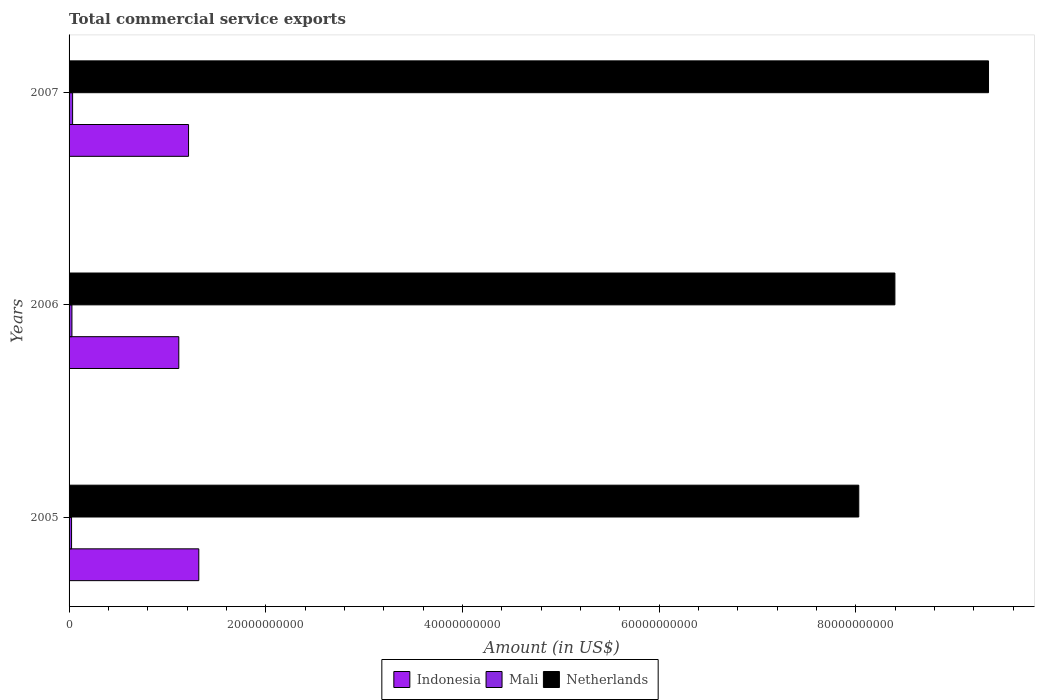How many different coloured bars are there?
Offer a very short reply. 3. How many groups of bars are there?
Offer a very short reply. 3. How many bars are there on the 2nd tick from the top?
Give a very brief answer. 3. What is the label of the 2nd group of bars from the top?
Keep it short and to the point. 2006. What is the total commercial service exports in Mali in 2005?
Offer a terse response. 2.54e+08. Across all years, what is the maximum total commercial service exports in Indonesia?
Your response must be concise. 1.32e+1. Across all years, what is the minimum total commercial service exports in Netherlands?
Offer a very short reply. 8.03e+1. What is the total total commercial service exports in Netherlands in the graph?
Ensure brevity in your answer.  2.58e+11. What is the difference between the total commercial service exports in Mali in 2006 and that in 2007?
Offer a terse response. -6.82e+07. What is the difference between the total commercial service exports in Mali in 2005 and the total commercial service exports in Indonesia in 2007?
Your answer should be very brief. -1.19e+1. What is the average total commercial service exports in Indonesia per year?
Ensure brevity in your answer.  1.22e+1. In the year 2005, what is the difference between the total commercial service exports in Netherlands and total commercial service exports in Mali?
Provide a short and direct response. 8.00e+1. In how many years, is the total commercial service exports in Netherlands greater than 20000000000 US$?
Make the answer very short. 3. What is the ratio of the total commercial service exports in Netherlands in 2005 to that in 2006?
Keep it short and to the point. 0.96. Is the total commercial service exports in Netherlands in 2005 less than that in 2006?
Provide a short and direct response. Yes. What is the difference between the highest and the second highest total commercial service exports in Netherlands?
Offer a very short reply. 9.52e+09. What is the difference between the highest and the lowest total commercial service exports in Indonesia?
Your answer should be compact. 2.03e+09. What does the 1st bar from the top in 2005 represents?
Your answer should be compact. Netherlands. What does the 1st bar from the bottom in 2005 represents?
Give a very brief answer. Indonesia. Is it the case that in every year, the sum of the total commercial service exports in Netherlands and total commercial service exports in Mali is greater than the total commercial service exports in Indonesia?
Make the answer very short. Yes. How many bars are there?
Provide a short and direct response. 9. How many years are there in the graph?
Give a very brief answer. 3. What is the difference between two consecutive major ticks on the X-axis?
Provide a short and direct response. 2.00e+1. Are the values on the major ticks of X-axis written in scientific E-notation?
Keep it short and to the point. No. Does the graph contain grids?
Offer a terse response. No. How many legend labels are there?
Make the answer very short. 3. How are the legend labels stacked?
Keep it short and to the point. Horizontal. What is the title of the graph?
Keep it short and to the point. Total commercial service exports. What is the label or title of the X-axis?
Ensure brevity in your answer.  Amount (in US$). What is the Amount (in US$) in Indonesia in 2005?
Your answer should be very brief. 1.32e+1. What is the Amount (in US$) in Mali in 2005?
Your answer should be very brief. 2.54e+08. What is the Amount (in US$) in Netherlands in 2005?
Your answer should be compact. 8.03e+1. What is the Amount (in US$) of Indonesia in 2006?
Keep it short and to the point. 1.12e+1. What is the Amount (in US$) of Mali in 2006?
Give a very brief answer. 2.91e+08. What is the Amount (in US$) in Netherlands in 2006?
Provide a succinct answer. 8.40e+1. What is the Amount (in US$) of Indonesia in 2007?
Give a very brief answer. 1.21e+1. What is the Amount (in US$) of Mali in 2007?
Provide a short and direct response. 3.60e+08. What is the Amount (in US$) of Netherlands in 2007?
Provide a succinct answer. 9.35e+1. Across all years, what is the maximum Amount (in US$) in Indonesia?
Ensure brevity in your answer.  1.32e+1. Across all years, what is the maximum Amount (in US$) of Mali?
Offer a terse response. 3.60e+08. Across all years, what is the maximum Amount (in US$) in Netherlands?
Your response must be concise. 9.35e+1. Across all years, what is the minimum Amount (in US$) of Indonesia?
Provide a succinct answer. 1.12e+1. Across all years, what is the minimum Amount (in US$) in Mali?
Offer a very short reply. 2.54e+08. Across all years, what is the minimum Amount (in US$) in Netherlands?
Offer a very short reply. 8.03e+1. What is the total Amount (in US$) of Indonesia in the graph?
Provide a succinct answer. 3.65e+1. What is the total Amount (in US$) in Mali in the graph?
Your response must be concise. 9.05e+08. What is the total Amount (in US$) in Netherlands in the graph?
Your answer should be very brief. 2.58e+11. What is the difference between the Amount (in US$) of Indonesia in 2005 and that in 2006?
Provide a succinct answer. 2.03e+09. What is the difference between the Amount (in US$) of Mali in 2005 and that in 2006?
Make the answer very short. -3.79e+07. What is the difference between the Amount (in US$) of Netherlands in 2005 and that in 2006?
Make the answer very short. -3.67e+09. What is the difference between the Amount (in US$) in Indonesia in 2005 and that in 2007?
Keep it short and to the point. 1.04e+09. What is the difference between the Amount (in US$) in Mali in 2005 and that in 2007?
Ensure brevity in your answer.  -1.06e+08. What is the difference between the Amount (in US$) of Netherlands in 2005 and that in 2007?
Ensure brevity in your answer.  -1.32e+1. What is the difference between the Amount (in US$) in Indonesia in 2006 and that in 2007?
Your answer should be very brief. -9.91e+08. What is the difference between the Amount (in US$) of Mali in 2006 and that in 2007?
Offer a very short reply. -6.82e+07. What is the difference between the Amount (in US$) in Netherlands in 2006 and that in 2007?
Provide a succinct answer. -9.52e+09. What is the difference between the Amount (in US$) of Indonesia in 2005 and the Amount (in US$) of Mali in 2006?
Make the answer very short. 1.29e+1. What is the difference between the Amount (in US$) of Indonesia in 2005 and the Amount (in US$) of Netherlands in 2006?
Make the answer very short. -7.08e+1. What is the difference between the Amount (in US$) of Mali in 2005 and the Amount (in US$) of Netherlands in 2006?
Give a very brief answer. -8.37e+1. What is the difference between the Amount (in US$) of Indonesia in 2005 and the Amount (in US$) of Mali in 2007?
Give a very brief answer. 1.28e+1. What is the difference between the Amount (in US$) of Indonesia in 2005 and the Amount (in US$) of Netherlands in 2007?
Your answer should be compact. -8.03e+1. What is the difference between the Amount (in US$) in Mali in 2005 and the Amount (in US$) in Netherlands in 2007?
Ensure brevity in your answer.  -9.32e+1. What is the difference between the Amount (in US$) of Indonesia in 2006 and the Amount (in US$) of Mali in 2007?
Give a very brief answer. 1.08e+1. What is the difference between the Amount (in US$) of Indonesia in 2006 and the Amount (in US$) of Netherlands in 2007?
Ensure brevity in your answer.  -8.23e+1. What is the difference between the Amount (in US$) of Mali in 2006 and the Amount (in US$) of Netherlands in 2007?
Your answer should be compact. -9.32e+1. What is the average Amount (in US$) of Indonesia per year?
Ensure brevity in your answer.  1.22e+1. What is the average Amount (in US$) of Mali per year?
Give a very brief answer. 3.02e+08. What is the average Amount (in US$) of Netherlands per year?
Your answer should be compact. 8.59e+1. In the year 2005, what is the difference between the Amount (in US$) of Indonesia and Amount (in US$) of Mali?
Your answer should be compact. 1.29e+1. In the year 2005, what is the difference between the Amount (in US$) in Indonesia and Amount (in US$) in Netherlands?
Give a very brief answer. -6.71e+1. In the year 2005, what is the difference between the Amount (in US$) of Mali and Amount (in US$) of Netherlands?
Ensure brevity in your answer.  -8.00e+1. In the year 2006, what is the difference between the Amount (in US$) of Indonesia and Amount (in US$) of Mali?
Offer a terse response. 1.09e+1. In the year 2006, what is the difference between the Amount (in US$) of Indonesia and Amount (in US$) of Netherlands?
Offer a terse response. -7.28e+1. In the year 2006, what is the difference between the Amount (in US$) in Mali and Amount (in US$) in Netherlands?
Your response must be concise. -8.37e+1. In the year 2007, what is the difference between the Amount (in US$) of Indonesia and Amount (in US$) of Mali?
Your answer should be compact. 1.18e+1. In the year 2007, what is the difference between the Amount (in US$) of Indonesia and Amount (in US$) of Netherlands?
Make the answer very short. -8.13e+1. In the year 2007, what is the difference between the Amount (in US$) in Mali and Amount (in US$) in Netherlands?
Offer a terse response. -9.31e+1. What is the ratio of the Amount (in US$) of Indonesia in 2005 to that in 2006?
Give a very brief answer. 1.18. What is the ratio of the Amount (in US$) of Mali in 2005 to that in 2006?
Provide a succinct answer. 0.87. What is the ratio of the Amount (in US$) in Netherlands in 2005 to that in 2006?
Provide a succinct answer. 0.96. What is the ratio of the Amount (in US$) in Indonesia in 2005 to that in 2007?
Your answer should be compact. 1.09. What is the ratio of the Amount (in US$) in Mali in 2005 to that in 2007?
Make the answer very short. 0.7. What is the ratio of the Amount (in US$) of Netherlands in 2005 to that in 2007?
Make the answer very short. 0.86. What is the ratio of the Amount (in US$) in Indonesia in 2006 to that in 2007?
Give a very brief answer. 0.92. What is the ratio of the Amount (in US$) of Mali in 2006 to that in 2007?
Provide a short and direct response. 0.81. What is the ratio of the Amount (in US$) in Netherlands in 2006 to that in 2007?
Your response must be concise. 0.9. What is the difference between the highest and the second highest Amount (in US$) in Indonesia?
Ensure brevity in your answer.  1.04e+09. What is the difference between the highest and the second highest Amount (in US$) of Mali?
Offer a terse response. 6.82e+07. What is the difference between the highest and the second highest Amount (in US$) in Netherlands?
Ensure brevity in your answer.  9.52e+09. What is the difference between the highest and the lowest Amount (in US$) in Indonesia?
Ensure brevity in your answer.  2.03e+09. What is the difference between the highest and the lowest Amount (in US$) of Mali?
Offer a terse response. 1.06e+08. What is the difference between the highest and the lowest Amount (in US$) in Netherlands?
Provide a succinct answer. 1.32e+1. 